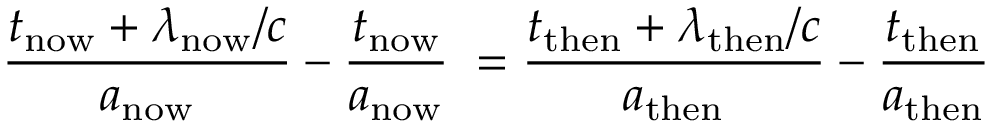Convert formula to latex. <formula><loc_0><loc_0><loc_500><loc_500>{ \frac { t _ { n o w } + \lambda _ { n o w } / c } { a _ { n o w } } } - { \frac { t _ { n o w } } { a _ { n o w } } } \, = { \frac { t _ { t h e n } + \lambda _ { t h e n } / c } { a _ { t h e n } } } - { \frac { t _ { t h e n } } { a _ { t h e n } } }</formula> 